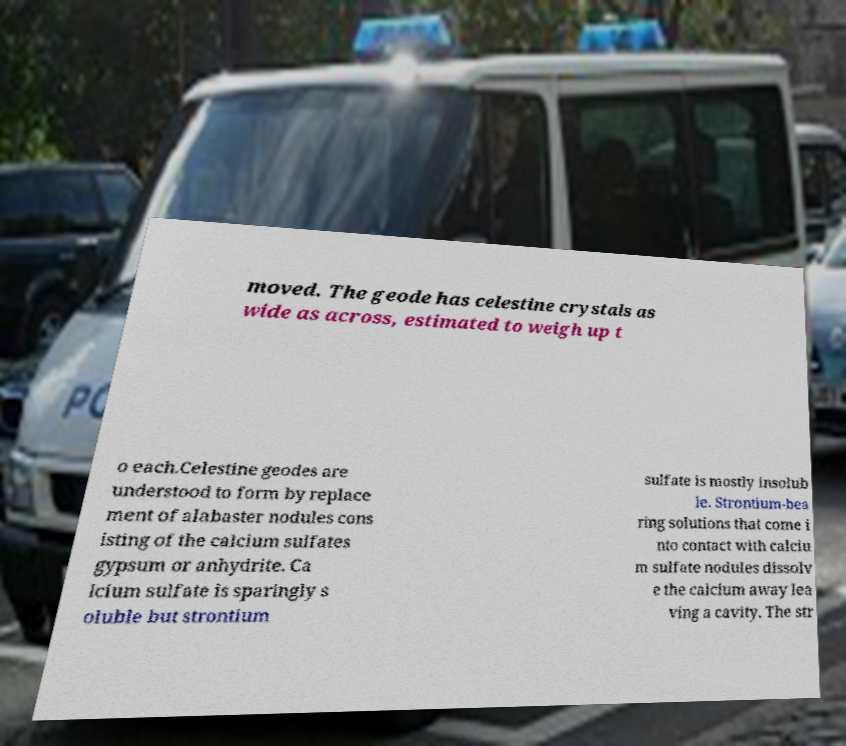Please read and relay the text visible in this image. What does it say? moved. The geode has celestine crystals as wide as across, estimated to weigh up t o each.Celestine geodes are understood to form by replace ment of alabaster nodules cons isting of the calcium sulfates gypsum or anhydrite. Ca lcium sulfate is sparingly s oluble but strontium sulfate is mostly insolub le. Strontium-bea ring solutions that come i nto contact with calciu m sulfate nodules dissolv e the calcium away lea ving a cavity. The str 